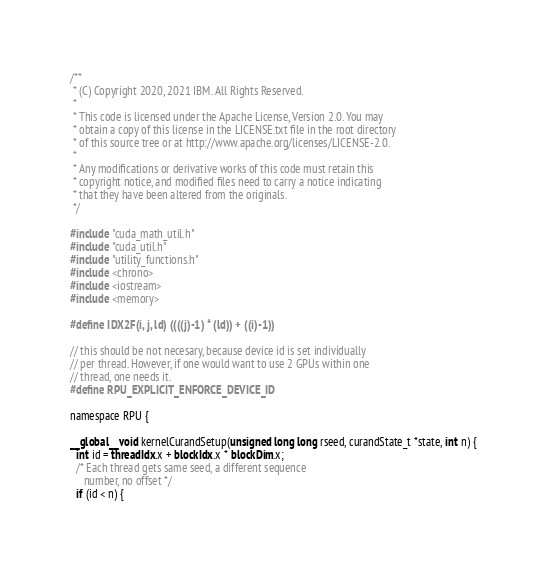Convert code to text. <code><loc_0><loc_0><loc_500><loc_500><_Cuda_>/**
 * (C) Copyright 2020, 2021 IBM. All Rights Reserved.
 *
 * This code is licensed under the Apache License, Version 2.0. You may
 * obtain a copy of this license in the LICENSE.txt file in the root directory
 * of this source tree or at http://www.apache.org/licenses/LICENSE-2.0.
 *
 * Any modifications or derivative works of this code must retain this
 * copyright notice, and modified files need to carry a notice indicating
 * that they have been altered from the originals.
 */

#include "cuda_math_util.h"
#include "cuda_util.h"
#include "utility_functions.h"
#include <chrono>
#include <iostream>
#include <memory>

#define IDX2F(i, j, ld) ((((j)-1) * (ld)) + ((i)-1))

// this should be not necesary, because device id is set individually
// per thread. However, if one would want to use 2 GPUs within one
// thread, one needs it.
#define RPU_EXPLICIT_ENFORCE_DEVICE_ID

namespace RPU {

__global__ void kernelCurandSetup(unsigned long long rseed, curandState_t *state, int n) {
  int id = threadIdx.x + blockIdx.x * blockDim.x;
  /* Each thread gets same seed, a different sequence
     number, no offset */
  if (id < n) {</code> 